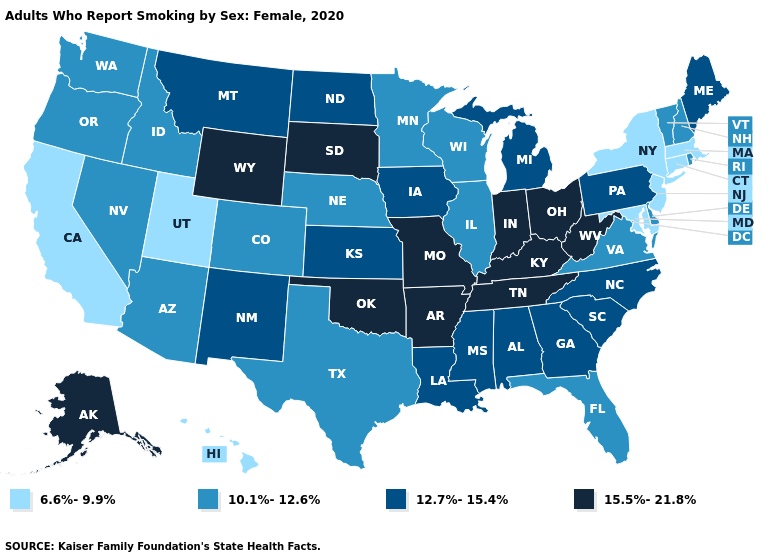Among the states that border Delaware , which have the lowest value?
Quick response, please. Maryland, New Jersey. What is the value of New York?
Concise answer only. 6.6%-9.9%. Among the states that border Tennessee , which have the lowest value?
Concise answer only. Virginia. Among the states that border South Dakota , which have the highest value?
Be succinct. Wyoming. Among the states that border Minnesota , does South Dakota have the highest value?
Answer briefly. Yes. What is the value of Oregon?
Answer briefly. 10.1%-12.6%. What is the lowest value in states that border New Jersey?
Short answer required. 6.6%-9.9%. Which states have the highest value in the USA?
Short answer required. Alaska, Arkansas, Indiana, Kentucky, Missouri, Ohio, Oklahoma, South Dakota, Tennessee, West Virginia, Wyoming. Name the states that have a value in the range 10.1%-12.6%?
Concise answer only. Arizona, Colorado, Delaware, Florida, Idaho, Illinois, Minnesota, Nebraska, Nevada, New Hampshire, Oregon, Rhode Island, Texas, Vermont, Virginia, Washington, Wisconsin. Name the states that have a value in the range 10.1%-12.6%?
Give a very brief answer. Arizona, Colorado, Delaware, Florida, Idaho, Illinois, Minnesota, Nebraska, Nevada, New Hampshire, Oregon, Rhode Island, Texas, Vermont, Virginia, Washington, Wisconsin. What is the value of West Virginia?
Short answer required. 15.5%-21.8%. What is the value of Indiana?
Answer briefly. 15.5%-21.8%. Does New York have the lowest value in the USA?
Give a very brief answer. Yes. Does the first symbol in the legend represent the smallest category?
Concise answer only. Yes. 